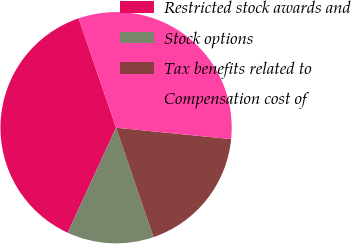<chart> <loc_0><loc_0><loc_500><loc_500><pie_chart><fcel>Restricted stock awards and<fcel>Stock options<fcel>Tax benefits related to<fcel>Compensation cost of<nl><fcel>37.88%<fcel>12.12%<fcel>18.18%<fcel>31.82%<nl></chart> 